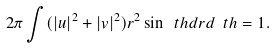Convert formula to latex. <formula><loc_0><loc_0><loc_500><loc_500>2 \pi \int ( | u | ^ { 2 } + | v | ^ { 2 } ) r ^ { 2 } \sin \ t h d r d \ t h = 1 .</formula> 